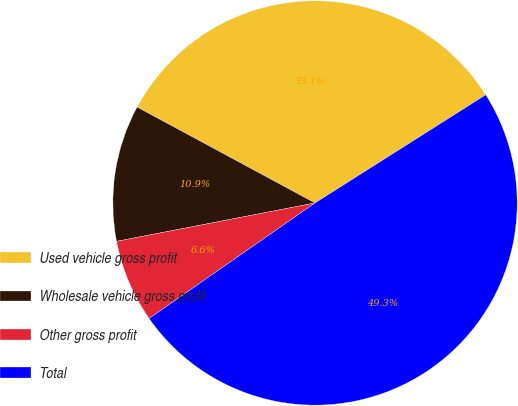Convert chart to OTSL. <chart><loc_0><loc_0><loc_500><loc_500><pie_chart><fcel>Used vehicle gross profit<fcel>Wholesale vehicle gross profit<fcel>Other gross profit<fcel>Total<nl><fcel>33.14%<fcel>10.91%<fcel>6.64%<fcel>49.31%<nl></chart> 